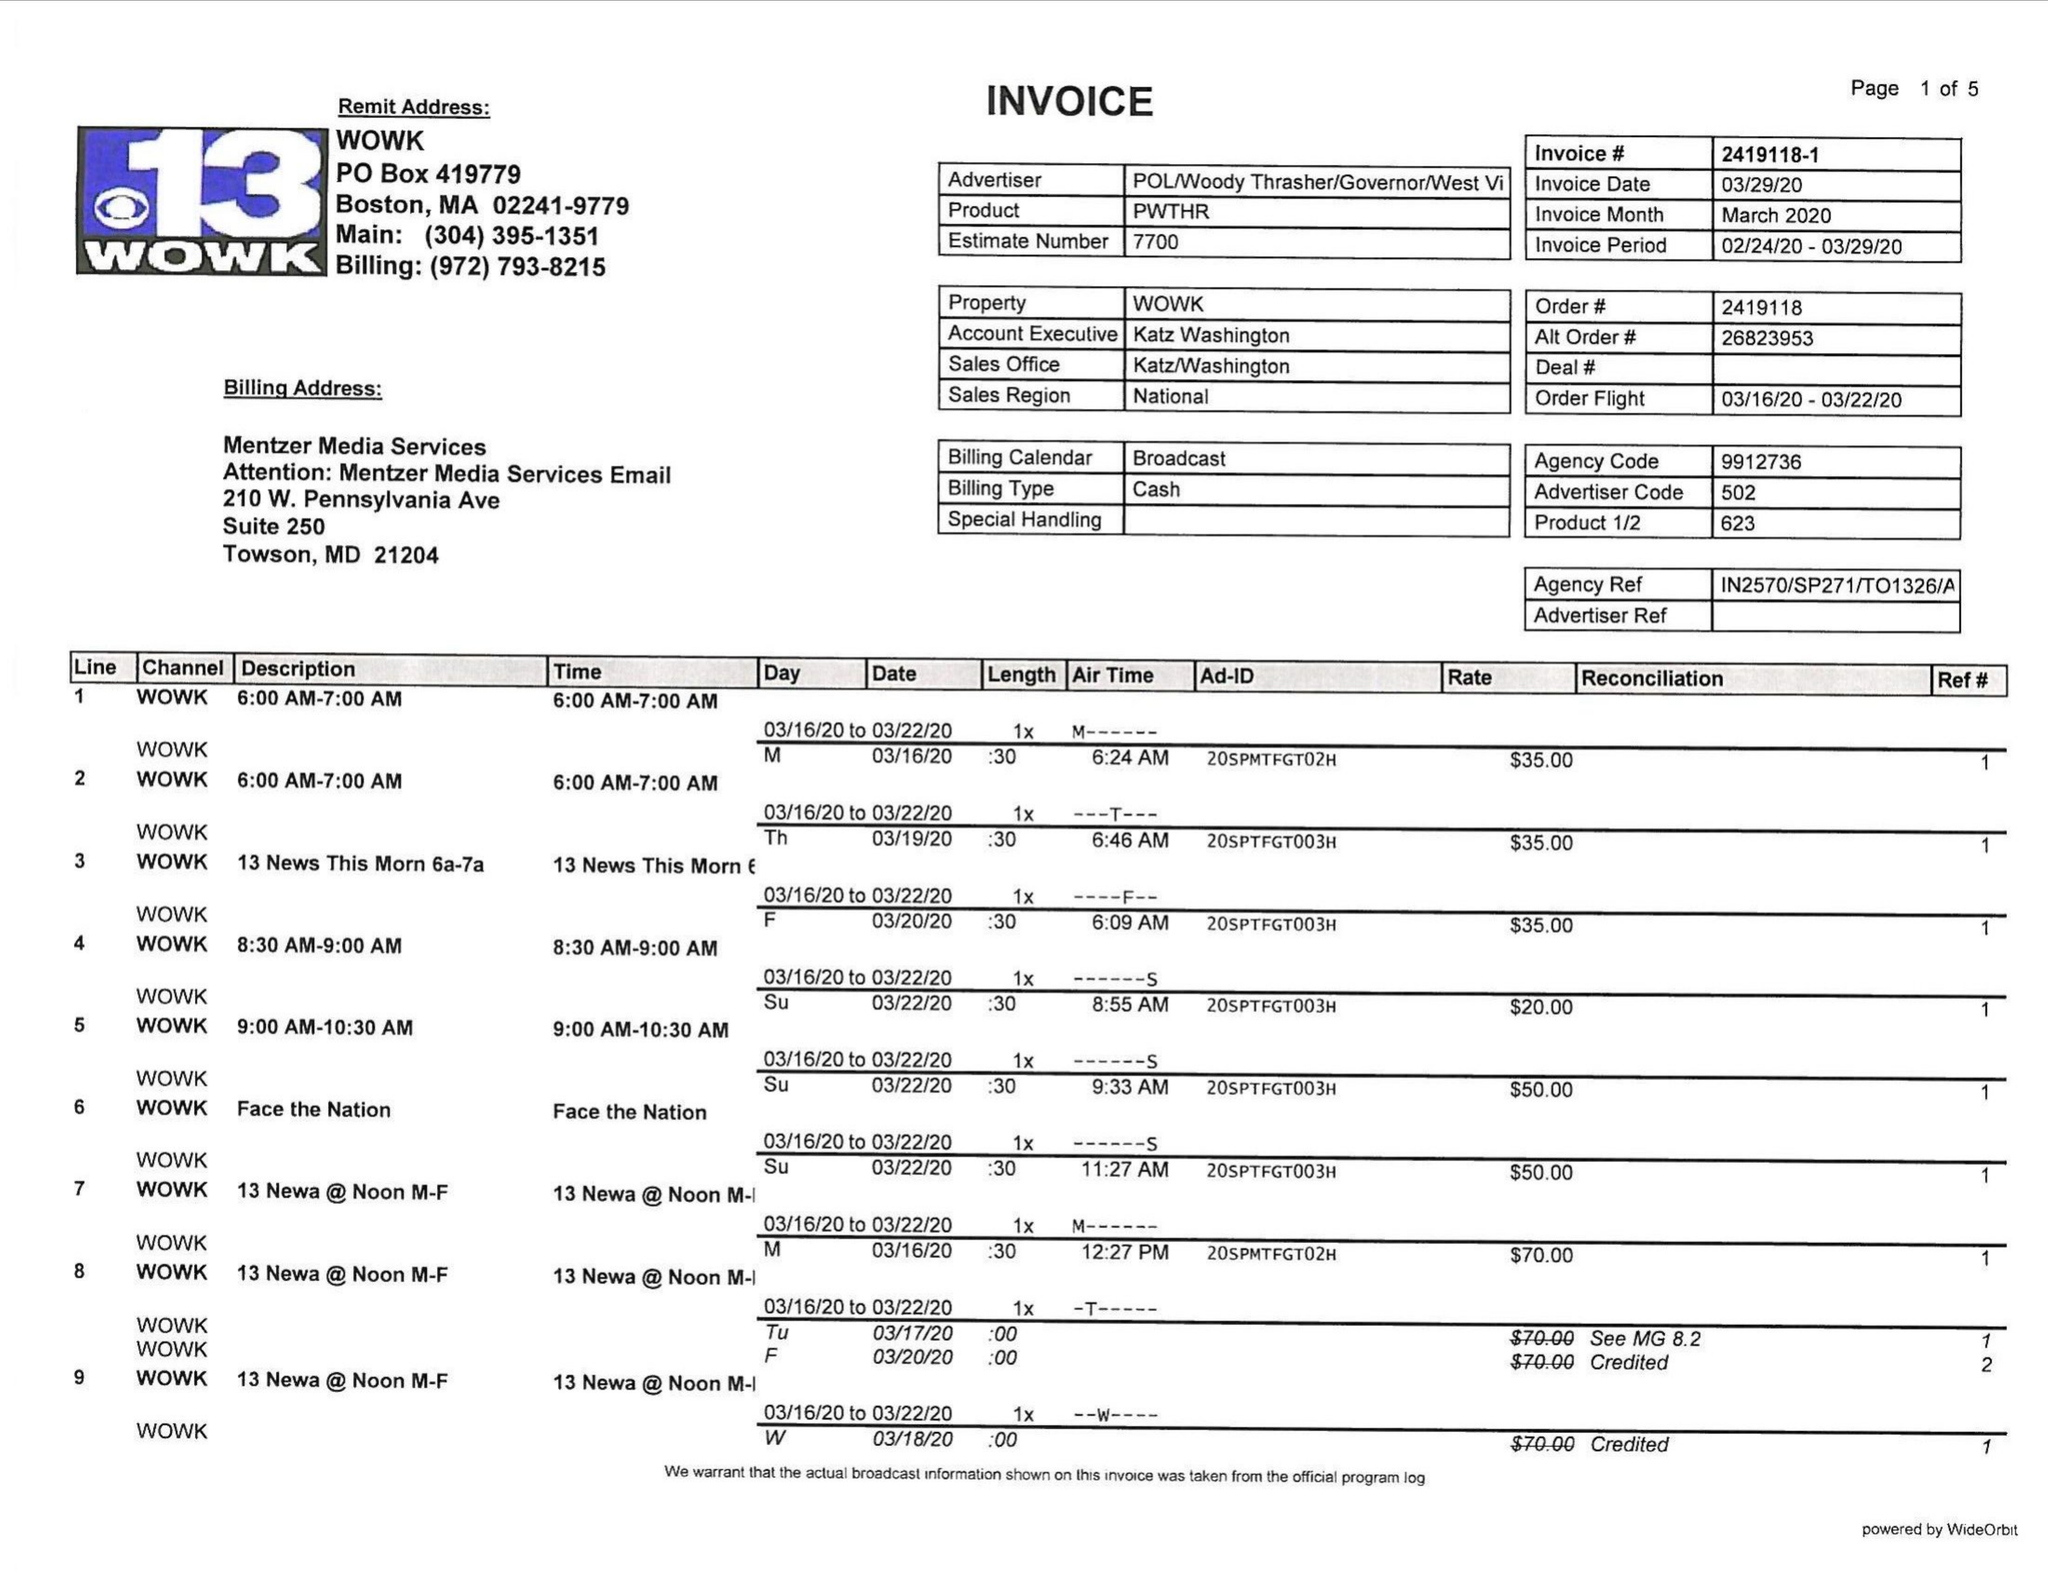What is the value for the flight_from?
Answer the question using a single word or phrase. 03/16/20 